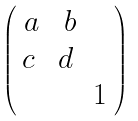Convert formula to latex. <formula><loc_0><loc_0><loc_500><loc_500>\begin{pmatrix} \ a & \ b & \ \\ c & d & \ \\ \ & \ & 1 \ \end{pmatrix}</formula> 